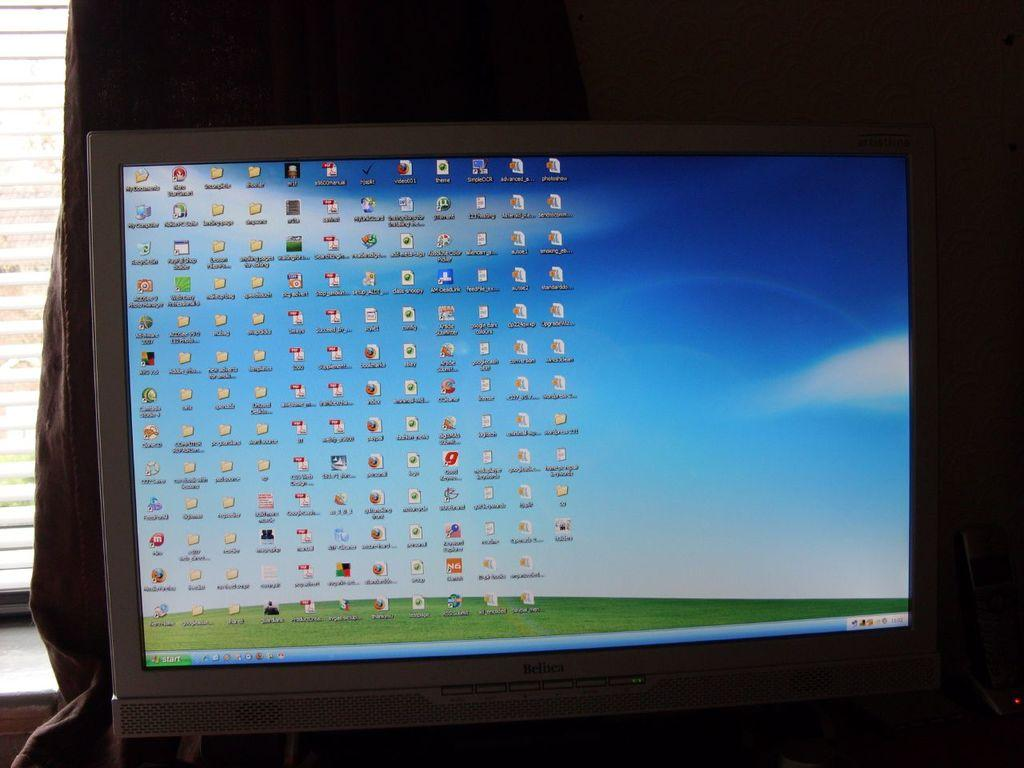What electronic device can be seen in the image? There is a PC in the image. What type of window treatment is present in the image? There is a curtain in the image. What type of structure is visible in the image? There is a wall in the image. Where was the image taken? The image was taken in a room. What type of pain is the person experiencing in the image? There is no person present in the image, and therefore no indication of any pain being experienced. 